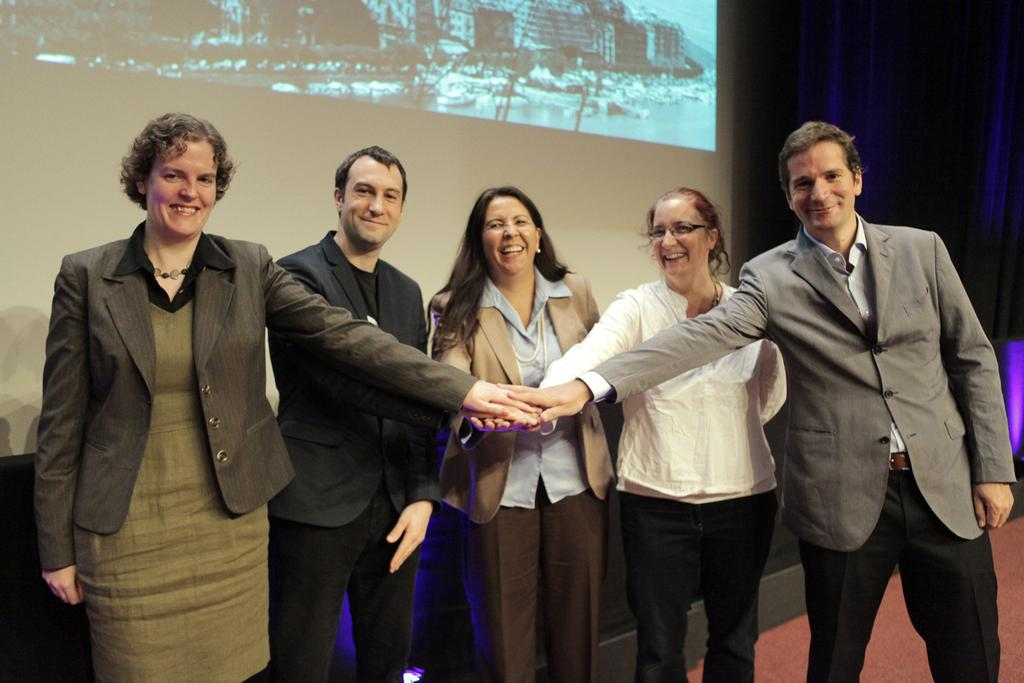What is the main subject of the image? The main subject of the image is a group of people. How can you describe the appearance of the people in the image? The people are wearing different color dresses. What object can be seen in the image besides the people? There is a screen in the image. What is the color of the background in the image? The background of the image is black. Reasoning: Let's think step by following the guidelines to produce the conversation. We start by identifying the main subject of the image, which is the group of people. Then, we describe their appearance by mentioning the different color dresses they are wearing. Next, we acknowledge the presence of another object in the image, which is the screen. Finally, we describe the background color, which is black. Absurd Question/Answer: How many stars can be seen on the dresses of the people in the image? There is no mention of stars on the dresses of the people in the image. Can you tell me how many geese are present in the image? There are no geese present in the image. What type of science experiment is being conducted in the image? There is no indication of a science experiment being conducted in the image. Can you tell me how many goose feathers are present in the image? There are no goose feathers present in the image. 